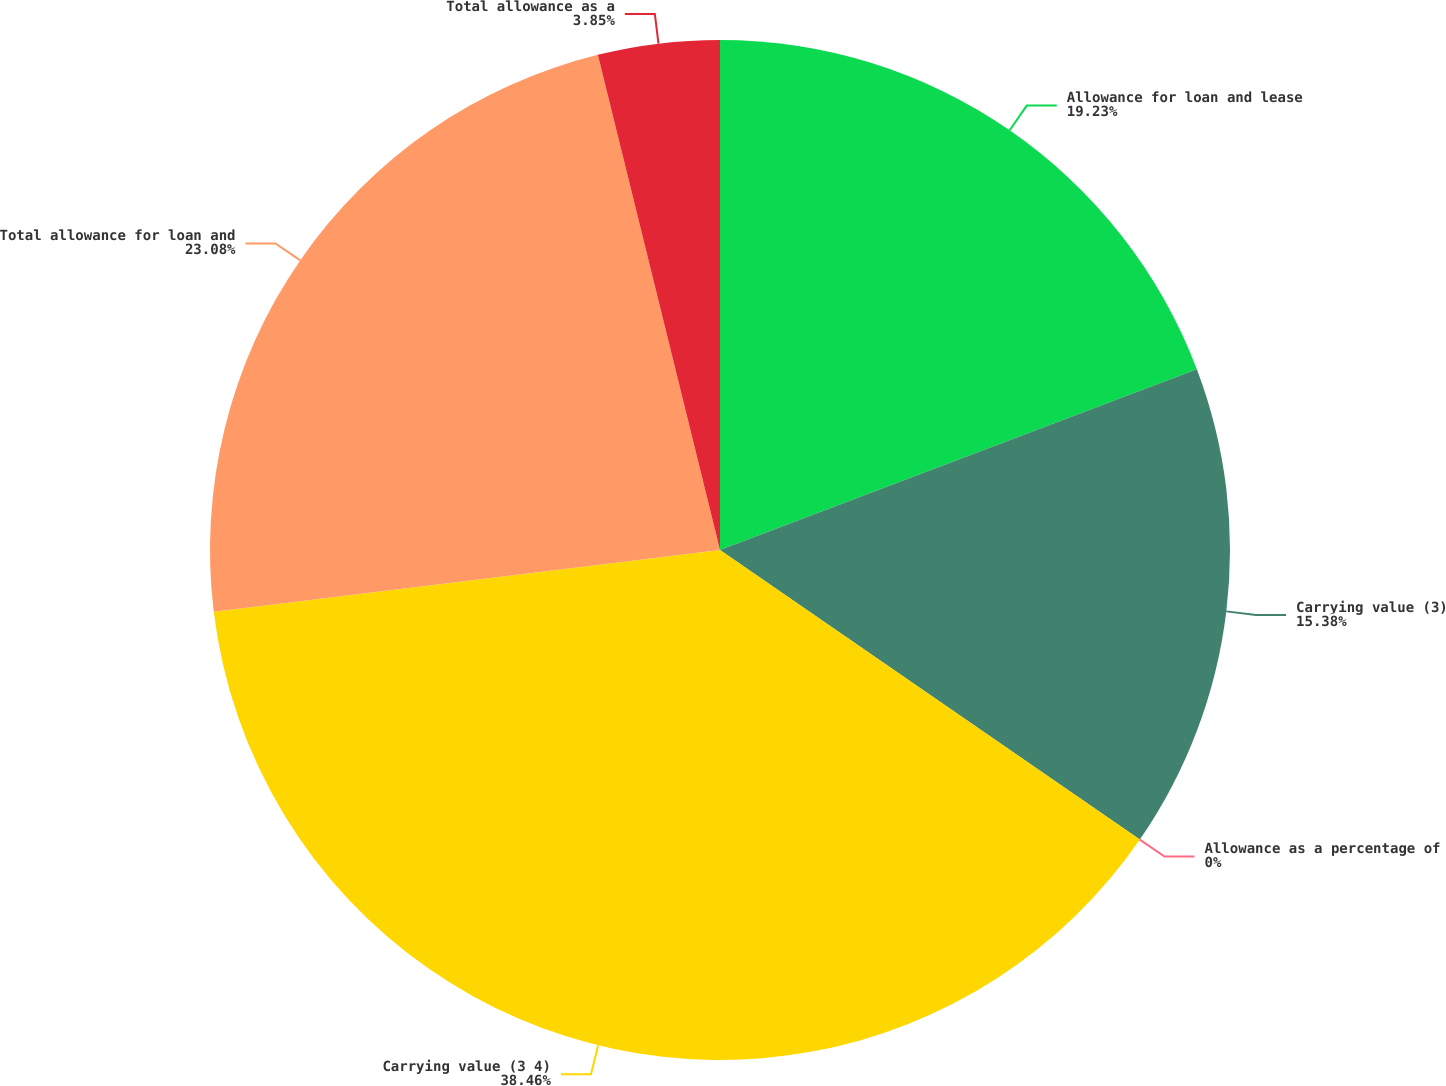<chart> <loc_0><loc_0><loc_500><loc_500><pie_chart><fcel>Allowance for loan and lease<fcel>Carrying value (3)<fcel>Allowance as a percentage of<fcel>Carrying value (3 4)<fcel>Total allowance for loan and<fcel>Total allowance as a<nl><fcel>19.23%<fcel>15.38%<fcel>0.0%<fcel>38.46%<fcel>23.08%<fcel>3.85%<nl></chart> 